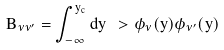Convert formula to latex. <formula><loc_0><loc_0><loc_500><loc_500>B _ { \nu \nu ^ { \prime } } = \int _ { - \infty } ^ { y _ { c } } d y \ > \phi _ { \nu } ( y ) \phi _ { \nu ^ { \prime } } ( y )</formula> 